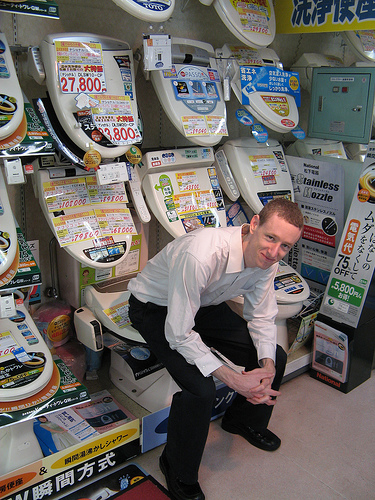Are the pants black or green? The boy's pants are definitely black, matching well with his overall attire. 